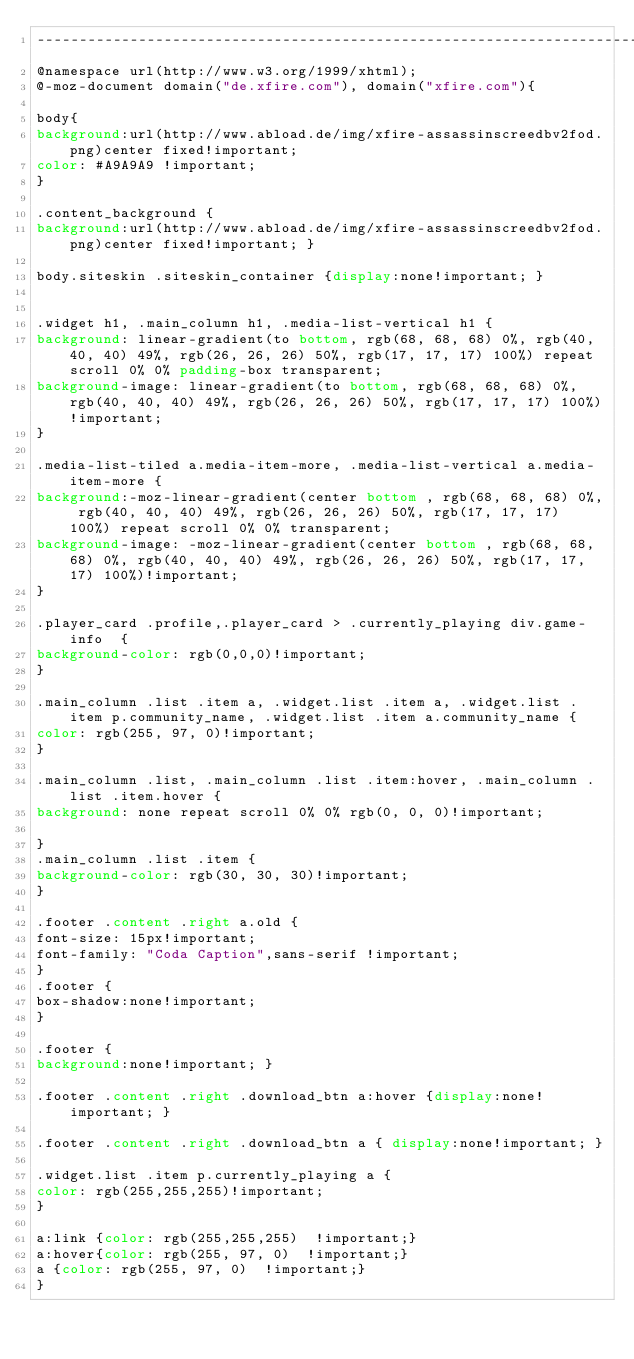<code> <loc_0><loc_0><loc_500><loc_500><_CSS_>----------------------------------------------------------------------------------------------*/
@namespace url(http://www.w3.org/1999/xhtml);
@-moz-document domain("de.xfire.com"), domain("xfire.com"){

body{
background:url(http://www.abload.de/img/xfire-assassinscreedbv2fod.png)center fixed!important;
color: #A9A9A9 !important;
}

.content_background {
background:url(http://www.abload.de/img/xfire-assassinscreedbv2fod.png)center fixed!important; }

body.siteskin .siteskin_container {display:none!important; }


.widget h1, .main_column h1, .media-list-vertical h1 {
background: linear-gradient(to bottom, rgb(68, 68, 68) 0%, rgb(40, 40, 40) 49%, rgb(26, 26, 26) 50%, rgb(17, 17, 17) 100%) repeat scroll 0% 0% padding-box transparent;
background-image: linear-gradient(to bottom, rgb(68, 68, 68) 0%, rgb(40, 40, 40) 49%, rgb(26, 26, 26) 50%, rgb(17, 17, 17) 100%)!important;
}

.media-list-tiled a.media-item-more, .media-list-vertical a.media-item-more {
background:-moz-linear-gradient(center bottom , rgb(68, 68, 68) 0%, rgb(40, 40, 40) 49%, rgb(26, 26, 26) 50%, rgb(17, 17, 17) 100%) repeat scroll 0% 0% transparent;
background-image: -moz-linear-gradient(center bottom , rgb(68, 68, 68) 0%, rgb(40, 40, 40) 49%, rgb(26, 26, 26) 50%, rgb(17, 17, 17) 100%)!important;
}

.player_card .profile,.player_card > .currently_playing div.game-info  {
background-color: rgb(0,0,0)!important;
}

.main_column .list .item a, .widget.list .item a, .widget.list .item p.community_name, .widget.list .item a.community_name {
color: rgb(255, 97, 0)!important;
}

.main_column .list, .main_column .list .item:hover, .main_column .list .item.hover {
background: none repeat scroll 0% 0% rgb(0, 0, 0)!important;

}
.main_column .list .item {
background-color: rgb(30, 30, 30)!important;
}

.footer .content .right a.old {
font-size: 15px!important;
font-family: "Coda Caption",sans-serif !important;
}
.footer {
box-shadow:none!important;
}

.footer { 
background:none!important; }

.footer .content .right .download_btn a:hover {display:none!important; }

.footer .content .right .download_btn a { display:none!important; }

.widget.list .item p.currently_playing a {
color: rgb(255,255,255)!important;
}

a:link {color: rgb(255,255,255)  !important;}
a:hover{color: rgb(255, 97, 0)  !important;}
a {color: rgb(255, 97, 0)  !important;}
}



</code> 